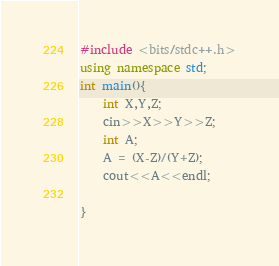Convert code to text. <code><loc_0><loc_0><loc_500><loc_500><_C++_>#include <bits/stdc++.h>
using namespace std;
int main(){
    int X,Y,Z;
    cin>>X>>Y>>Z;
    int A;
    A = (X-Z)/(Y+Z);
    cout<<A<<endl;

}</code> 